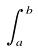Convert formula to latex. <formula><loc_0><loc_0><loc_500><loc_500>\int _ { a } ^ { b }</formula> 